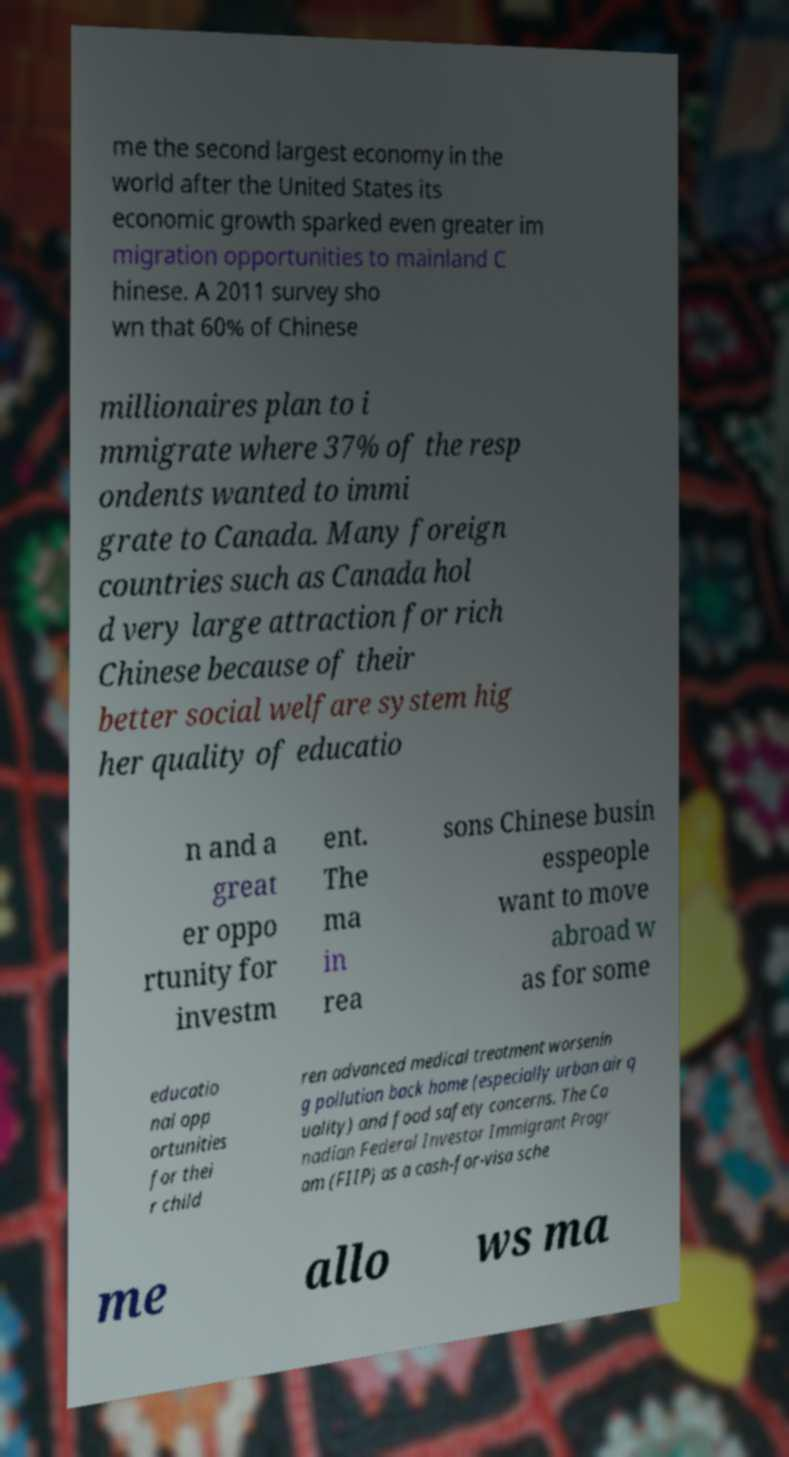Could you assist in decoding the text presented in this image and type it out clearly? me the second largest economy in the world after the United States its economic growth sparked even greater im migration opportunities to mainland C hinese. A 2011 survey sho wn that 60% of Chinese millionaires plan to i mmigrate where 37% of the resp ondents wanted to immi grate to Canada. Many foreign countries such as Canada hol d very large attraction for rich Chinese because of their better social welfare system hig her quality of educatio n and a great er oppo rtunity for investm ent. The ma in rea sons Chinese busin esspeople want to move abroad w as for some educatio nal opp ortunities for thei r child ren advanced medical treatment worsenin g pollution back home (especially urban air q uality) and food safety concerns. The Ca nadian Federal Investor Immigrant Progr am (FIIP) as a cash-for-visa sche me allo ws ma 